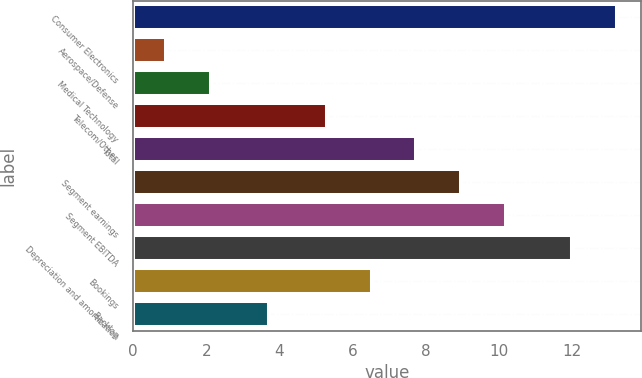<chart> <loc_0><loc_0><loc_500><loc_500><bar_chart><fcel>Consumer Electronics<fcel>Aerospace/Defense<fcel>Medical Technology<fcel>Telecom/Other<fcel>Total<fcel>Segment earnings<fcel>Segment EBITDA<fcel>Depreciation and amortization<fcel>Bookings<fcel>Backlog<nl><fcel>13.22<fcel>0.9<fcel>2.12<fcel>5.3<fcel>7.74<fcel>8.96<fcel>10.18<fcel>12<fcel>6.52<fcel>3.7<nl></chart> 